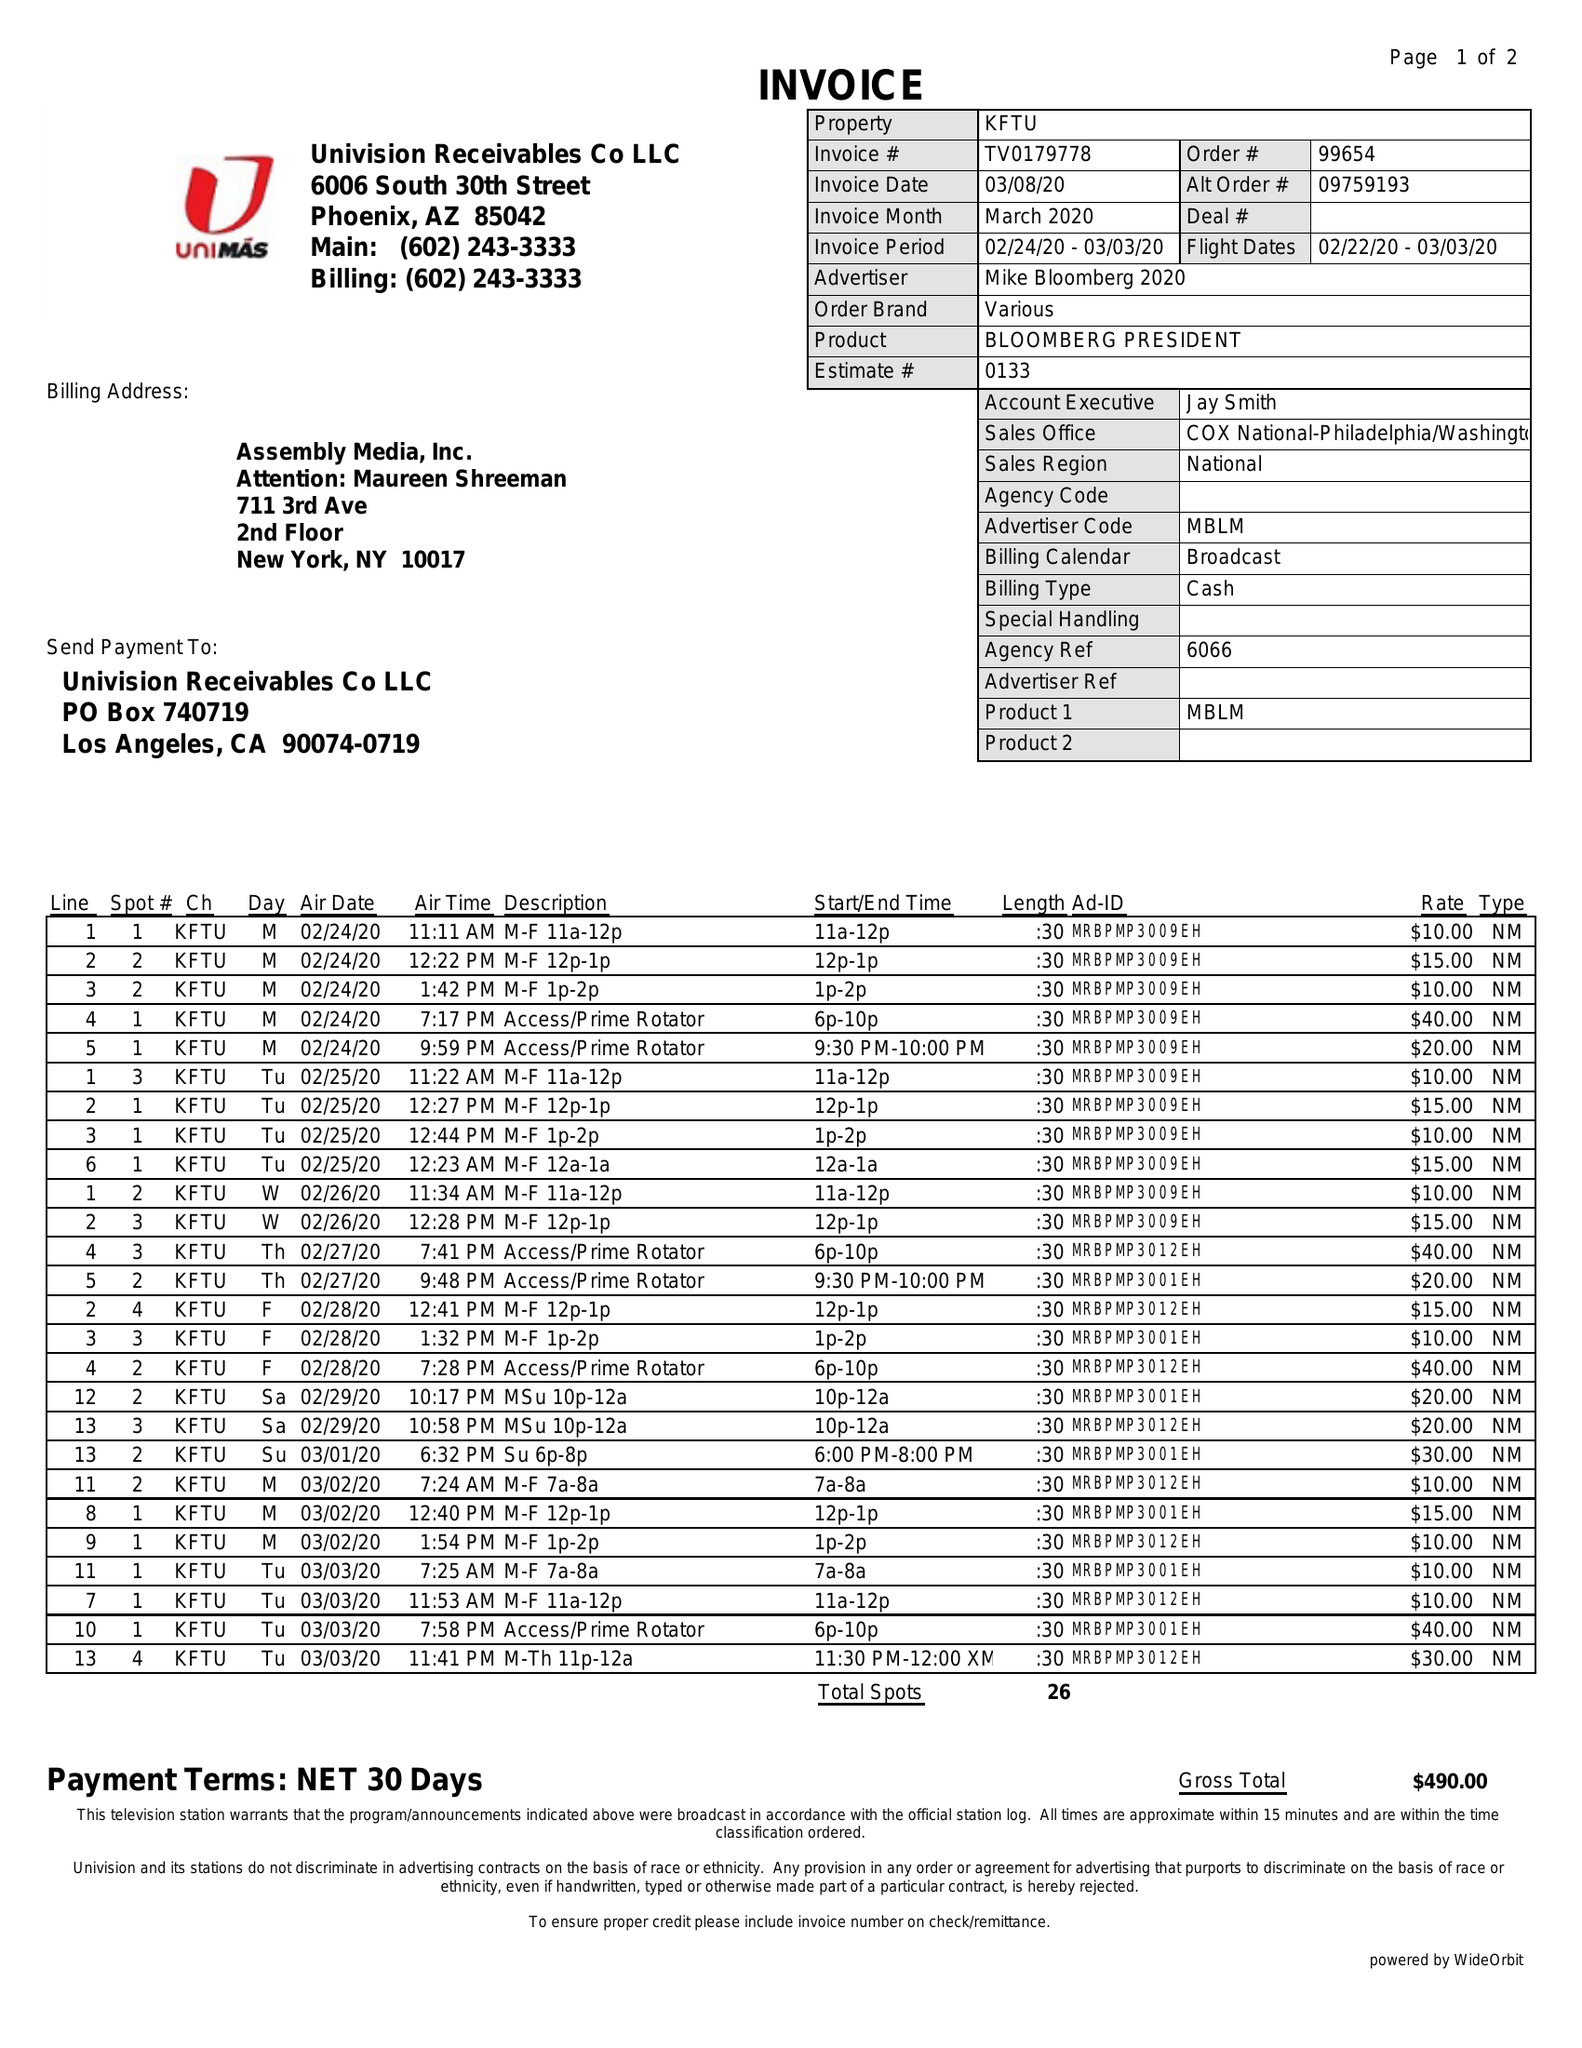What is the value for the advertiser?
Answer the question using a single word or phrase. MIKE BLOOMBERG 2020 